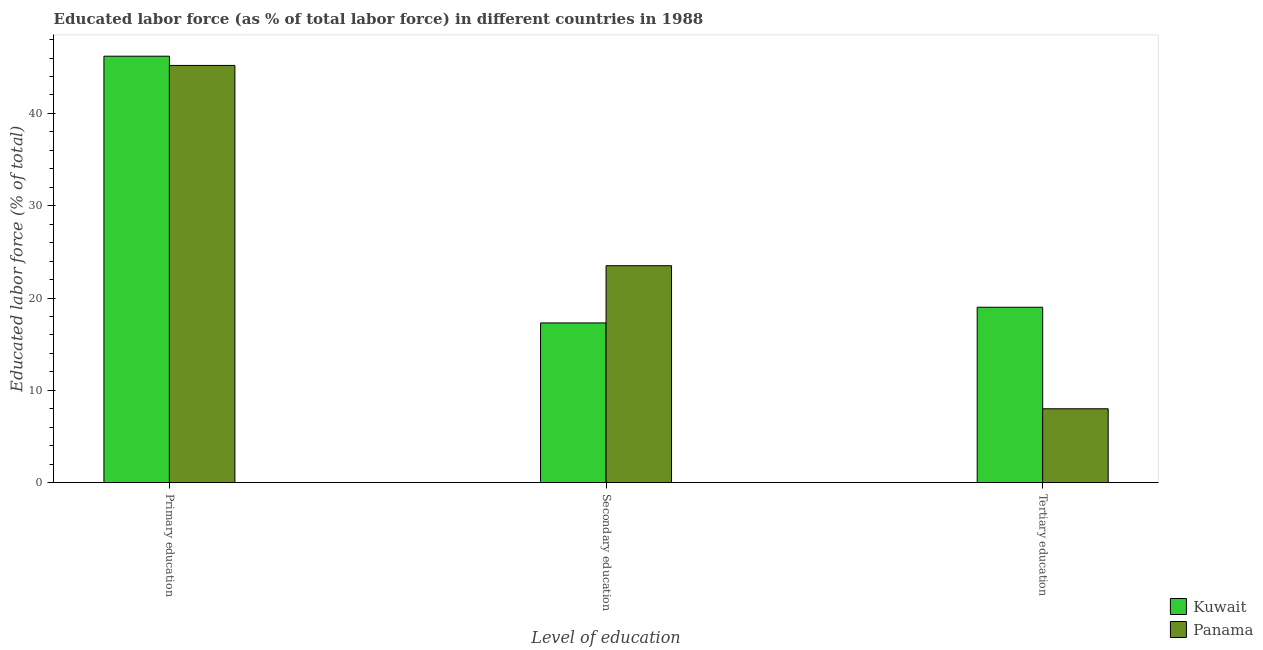How many bars are there on the 3rd tick from the left?
Make the answer very short. 2. What is the label of the 3rd group of bars from the left?
Your answer should be compact. Tertiary education. What is the percentage of labor force who received secondary education in Kuwait?
Give a very brief answer. 17.3. Across all countries, what is the minimum percentage of labor force who received tertiary education?
Keep it short and to the point. 8. In which country was the percentage of labor force who received primary education maximum?
Give a very brief answer. Kuwait. In which country was the percentage of labor force who received secondary education minimum?
Keep it short and to the point. Kuwait. What is the difference between the percentage of labor force who received primary education in Panama and that in Kuwait?
Provide a succinct answer. -1. What is the difference between the percentage of labor force who received primary education in Kuwait and the percentage of labor force who received secondary education in Panama?
Your answer should be very brief. 22.7. What is the average percentage of labor force who received primary education per country?
Your response must be concise. 45.7. What is the difference between the percentage of labor force who received secondary education and percentage of labor force who received primary education in Panama?
Make the answer very short. -21.7. What is the ratio of the percentage of labor force who received tertiary education in Kuwait to that in Panama?
Make the answer very short. 2.38. Is the percentage of labor force who received secondary education in Kuwait less than that in Panama?
Your answer should be compact. Yes. Is the difference between the percentage of labor force who received secondary education in Panama and Kuwait greater than the difference between the percentage of labor force who received primary education in Panama and Kuwait?
Give a very brief answer. Yes. What is the difference between the highest and the second highest percentage of labor force who received secondary education?
Provide a succinct answer. 6.2. What is the difference between the highest and the lowest percentage of labor force who received secondary education?
Offer a terse response. 6.2. Is the sum of the percentage of labor force who received primary education in Panama and Kuwait greater than the maximum percentage of labor force who received tertiary education across all countries?
Make the answer very short. Yes. What does the 2nd bar from the left in Primary education represents?
Make the answer very short. Panama. What does the 1st bar from the right in Primary education represents?
Keep it short and to the point. Panama. How many bars are there?
Ensure brevity in your answer.  6. What is the difference between two consecutive major ticks on the Y-axis?
Your answer should be very brief. 10. Are the values on the major ticks of Y-axis written in scientific E-notation?
Provide a succinct answer. No. Does the graph contain grids?
Keep it short and to the point. No. Where does the legend appear in the graph?
Ensure brevity in your answer.  Bottom right. How many legend labels are there?
Your answer should be compact. 2. How are the legend labels stacked?
Provide a succinct answer. Vertical. What is the title of the graph?
Your answer should be very brief. Educated labor force (as % of total labor force) in different countries in 1988. What is the label or title of the X-axis?
Make the answer very short. Level of education. What is the label or title of the Y-axis?
Your answer should be compact. Educated labor force (% of total). What is the Educated labor force (% of total) of Kuwait in Primary education?
Provide a succinct answer. 46.2. What is the Educated labor force (% of total) of Panama in Primary education?
Give a very brief answer. 45.2. What is the Educated labor force (% of total) in Kuwait in Secondary education?
Your answer should be compact. 17.3. What is the Educated labor force (% of total) of Kuwait in Tertiary education?
Provide a short and direct response. 19. What is the Educated labor force (% of total) in Panama in Tertiary education?
Provide a succinct answer. 8. Across all Level of education, what is the maximum Educated labor force (% of total) of Kuwait?
Make the answer very short. 46.2. Across all Level of education, what is the maximum Educated labor force (% of total) of Panama?
Make the answer very short. 45.2. Across all Level of education, what is the minimum Educated labor force (% of total) in Kuwait?
Offer a very short reply. 17.3. Across all Level of education, what is the minimum Educated labor force (% of total) of Panama?
Your response must be concise. 8. What is the total Educated labor force (% of total) in Kuwait in the graph?
Keep it short and to the point. 82.5. What is the total Educated labor force (% of total) of Panama in the graph?
Your answer should be compact. 76.7. What is the difference between the Educated labor force (% of total) of Kuwait in Primary education and that in Secondary education?
Keep it short and to the point. 28.9. What is the difference between the Educated labor force (% of total) in Panama in Primary education and that in Secondary education?
Provide a short and direct response. 21.7. What is the difference between the Educated labor force (% of total) in Kuwait in Primary education and that in Tertiary education?
Give a very brief answer. 27.2. What is the difference between the Educated labor force (% of total) of Panama in Primary education and that in Tertiary education?
Provide a succinct answer. 37.2. What is the difference between the Educated labor force (% of total) in Kuwait in Secondary education and that in Tertiary education?
Offer a very short reply. -1.7. What is the difference between the Educated labor force (% of total) of Panama in Secondary education and that in Tertiary education?
Provide a succinct answer. 15.5. What is the difference between the Educated labor force (% of total) in Kuwait in Primary education and the Educated labor force (% of total) in Panama in Secondary education?
Provide a succinct answer. 22.7. What is the difference between the Educated labor force (% of total) of Kuwait in Primary education and the Educated labor force (% of total) of Panama in Tertiary education?
Offer a very short reply. 38.2. What is the difference between the Educated labor force (% of total) in Kuwait in Secondary education and the Educated labor force (% of total) in Panama in Tertiary education?
Give a very brief answer. 9.3. What is the average Educated labor force (% of total) in Kuwait per Level of education?
Offer a terse response. 27.5. What is the average Educated labor force (% of total) of Panama per Level of education?
Offer a very short reply. 25.57. What is the difference between the Educated labor force (% of total) of Kuwait and Educated labor force (% of total) of Panama in Primary education?
Keep it short and to the point. 1. What is the difference between the Educated labor force (% of total) in Kuwait and Educated labor force (% of total) in Panama in Secondary education?
Provide a short and direct response. -6.2. What is the difference between the Educated labor force (% of total) in Kuwait and Educated labor force (% of total) in Panama in Tertiary education?
Your answer should be very brief. 11. What is the ratio of the Educated labor force (% of total) of Kuwait in Primary education to that in Secondary education?
Provide a succinct answer. 2.67. What is the ratio of the Educated labor force (% of total) of Panama in Primary education to that in Secondary education?
Offer a very short reply. 1.92. What is the ratio of the Educated labor force (% of total) in Kuwait in Primary education to that in Tertiary education?
Your answer should be compact. 2.43. What is the ratio of the Educated labor force (% of total) of Panama in Primary education to that in Tertiary education?
Offer a terse response. 5.65. What is the ratio of the Educated labor force (% of total) in Kuwait in Secondary education to that in Tertiary education?
Provide a succinct answer. 0.91. What is the ratio of the Educated labor force (% of total) of Panama in Secondary education to that in Tertiary education?
Give a very brief answer. 2.94. What is the difference between the highest and the second highest Educated labor force (% of total) in Kuwait?
Make the answer very short. 27.2. What is the difference between the highest and the second highest Educated labor force (% of total) in Panama?
Make the answer very short. 21.7. What is the difference between the highest and the lowest Educated labor force (% of total) in Kuwait?
Offer a very short reply. 28.9. What is the difference between the highest and the lowest Educated labor force (% of total) of Panama?
Your answer should be very brief. 37.2. 